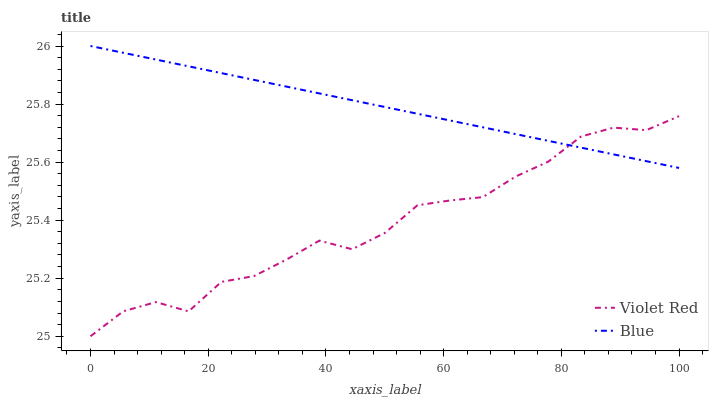Does Violet Red have the maximum area under the curve?
Answer yes or no. No. Is Violet Red the smoothest?
Answer yes or no. No. Does Violet Red have the highest value?
Answer yes or no. No. 